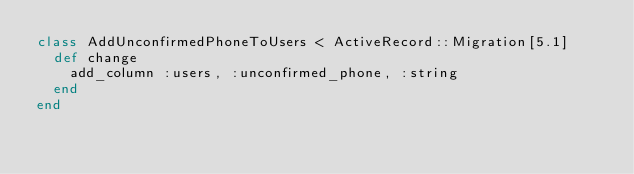Convert code to text. <code><loc_0><loc_0><loc_500><loc_500><_Ruby_>class AddUnconfirmedPhoneToUsers < ActiveRecord::Migration[5.1]
  def change
    add_column :users, :unconfirmed_phone, :string
  end
end
</code> 